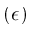Convert formula to latex. <formula><loc_0><loc_0><loc_500><loc_500>( \epsilon )</formula> 